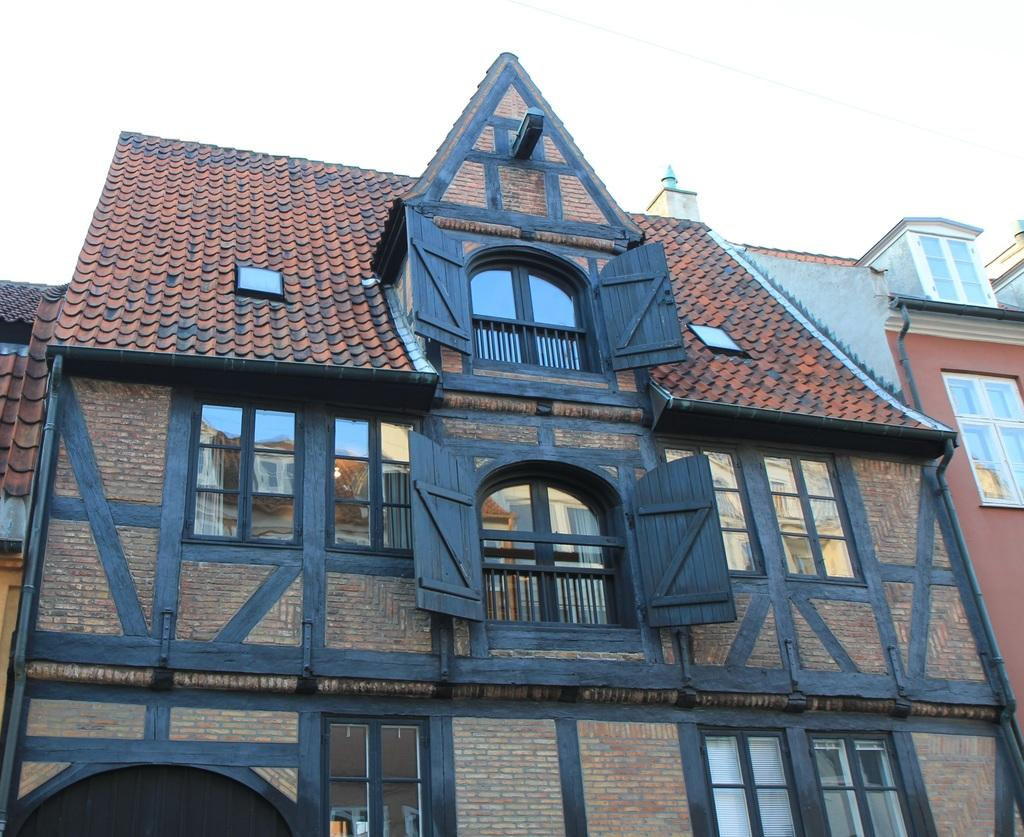What type of structures are present in the image? There are buildings in the image. What features can be observed on the buildings? The buildings have windows and iron grills. What can be seen in the background of the image? The sky is visible in the background of the image. Is there a wristwatch visible on any of the buildings in the image? There is no wristwatch present in the image; it features buildings with windows and iron grills. Can you see any fights taking place in the image? There is no fight depicted in the image; it shows buildings with windows and iron grills against the backdrop of the sky. 